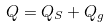<formula> <loc_0><loc_0><loc_500><loc_500>Q = Q _ { S } + Q _ { g }</formula> 